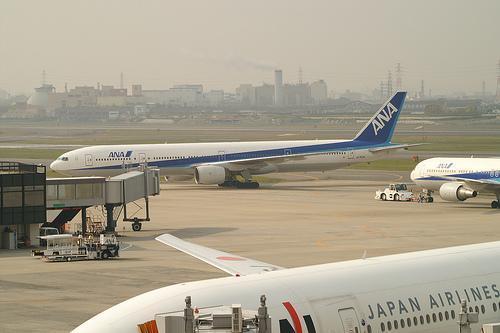How many planes are visible?
Give a very brief answer. 3. 